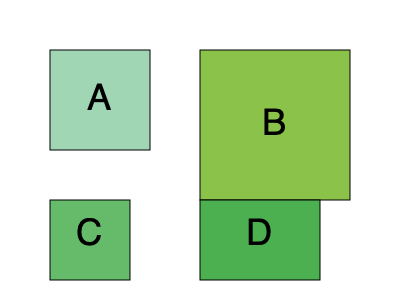Four eco-friendly packaging designs (A, B, C, and D) are shown above. If the volume of package A is 1000 cm³, which package has the highest volume-to-surface area ratio, indicating the most spatially efficient design for reducing packaging material? To determine the most spatially efficient design, we need to calculate the volume-to-surface area ratio for each package. Let's assume package A has dimensions of 10x10x10 cm.

1. Package A (10x10x10 cm):
   Volume = $10 \times 10 \times 10 = 1000$ cm³
   Surface Area = $6 \times 10^2 = 600$ cm²
   Ratio = $\frac{1000}{600} = 1.67$

2. Package B (15x15x10 cm, assuming depth is the same as A):
   Volume = $15 \times 15 \times 10 = 2250$ cm³
   Surface Area = $2(15 \times 15) + 4(15 \times 10) = 1050$ cm²
   Ratio = $\frac{2250}{1050} \approx 2.14$

3. Package C (8x8x8 cm, assuming it's a cube):
   Volume = $8 \times 8 \times 8 = 512$ cm³
   Surface Area = $6 \times 8^2 = 384$ cm²
   Ratio = $\frac{512}{384} = 1.33$

4. Package D (12x12x10 cm, assuming depth is the same as A):
   Volume = $12 \times 12 \times 10 = 1440$ cm³
   Surface Area = $2(12 \times 12) + 4(12 \times 10) = 768$ cm²
   Ratio = $\frac{1440}{768} = 1.875$

Package B has the highest volume-to-surface area ratio, making it the most spatially efficient design for reducing packaging material.
Answer: Package B 